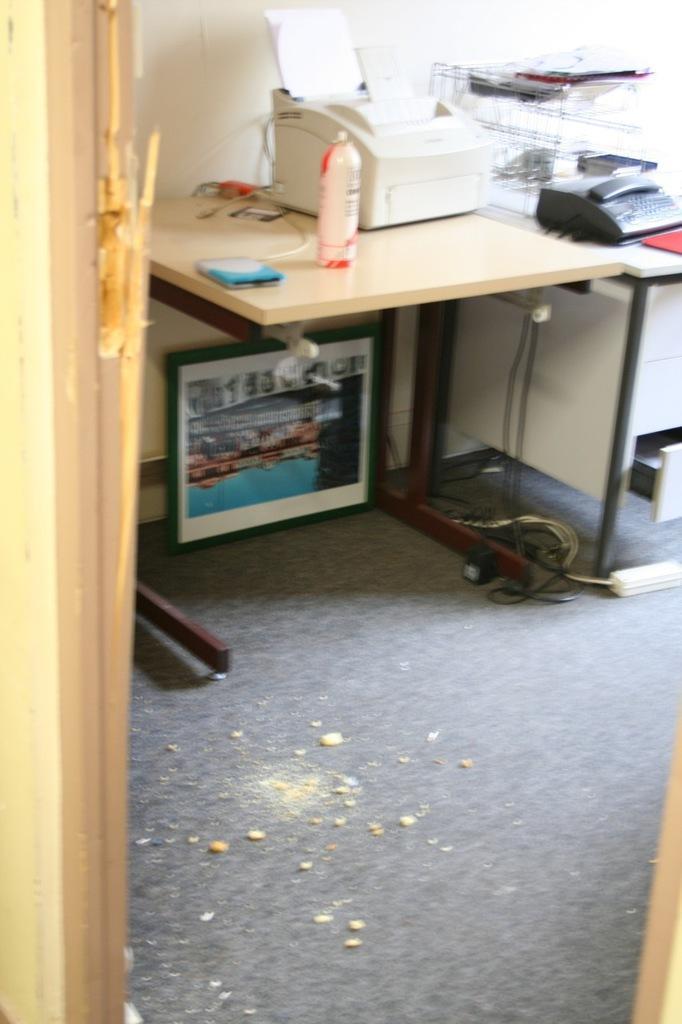Could you give a brief overview of what you see in this image? In this picture there is a xerox machine, papers , bottle, phone, telephone and other objects on the table. there is a frame. There is rod and a carpet. There is a switchboard and a wire. 